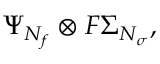<formula> <loc_0><loc_0><loc_500><loc_500>\Psi _ { N _ { f } } \otimes F \Sigma _ { N _ { \sigma } } ,</formula> 